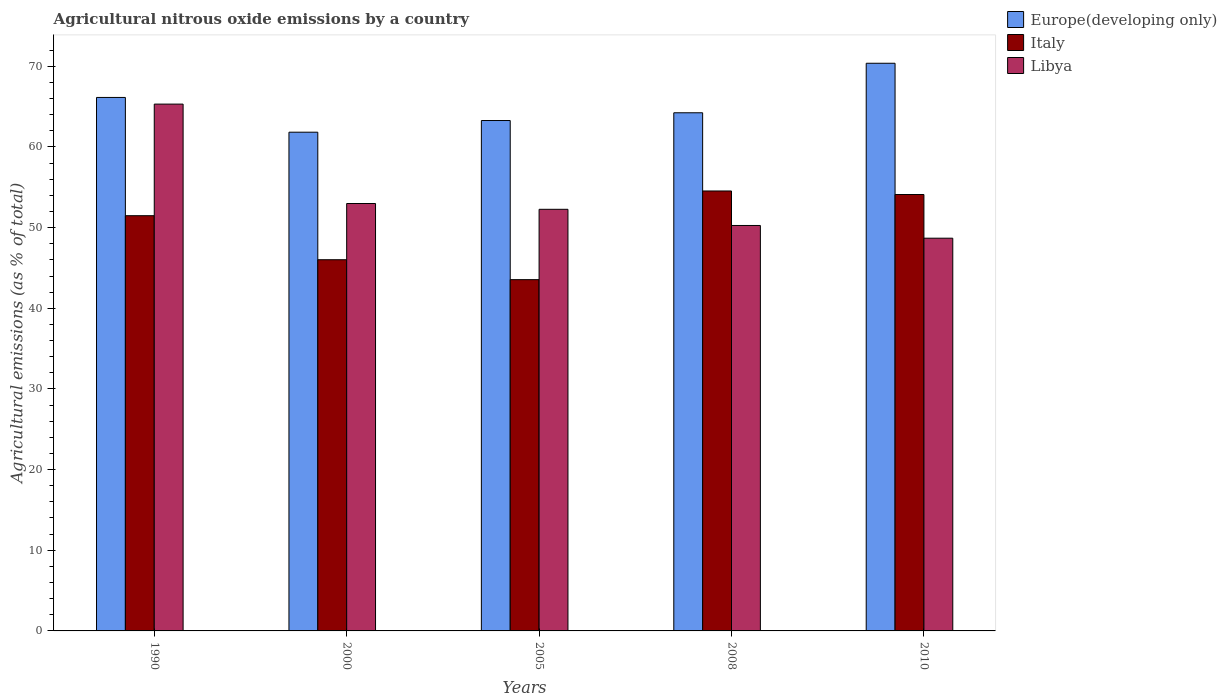How many different coloured bars are there?
Your answer should be compact. 3. How many groups of bars are there?
Offer a very short reply. 5. Are the number of bars per tick equal to the number of legend labels?
Make the answer very short. Yes. What is the amount of agricultural nitrous oxide emitted in Europe(developing only) in 2008?
Provide a short and direct response. 64.24. Across all years, what is the maximum amount of agricultural nitrous oxide emitted in Italy?
Ensure brevity in your answer.  54.54. Across all years, what is the minimum amount of agricultural nitrous oxide emitted in Europe(developing only)?
Keep it short and to the point. 61.83. In which year was the amount of agricultural nitrous oxide emitted in Libya maximum?
Give a very brief answer. 1990. In which year was the amount of agricultural nitrous oxide emitted in Europe(developing only) minimum?
Provide a short and direct response. 2000. What is the total amount of agricultural nitrous oxide emitted in Italy in the graph?
Keep it short and to the point. 249.69. What is the difference between the amount of agricultural nitrous oxide emitted in Italy in 2008 and that in 2010?
Give a very brief answer. 0.44. What is the difference between the amount of agricultural nitrous oxide emitted in Europe(developing only) in 2008 and the amount of agricultural nitrous oxide emitted in Italy in 2010?
Provide a short and direct response. 10.13. What is the average amount of agricultural nitrous oxide emitted in Europe(developing only) per year?
Offer a terse response. 65.17. In the year 1990, what is the difference between the amount of agricultural nitrous oxide emitted in Europe(developing only) and amount of agricultural nitrous oxide emitted in Italy?
Offer a terse response. 14.66. In how many years, is the amount of agricultural nitrous oxide emitted in Libya greater than 16 %?
Your response must be concise. 5. What is the ratio of the amount of agricultural nitrous oxide emitted in Europe(developing only) in 1990 to that in 2000?
Give a very brief answer. 1.07. Is the difference between the amount of agricultural nitrous oxide emitted in Europe(developing only) in 2005 and 2010 greater than the difference between the amount of agricultural nitrous oxide emitted in Italy in 2005 and 2010?
Provide a short and direct response. Yes. What is the difference between the highest and the second highest amount of agricultural nitrous oxide emitted in Europe(developing only)?
Offer a terse response. 4.24. What is the difference between the highest and the lowest amount of agricultural nitrous oxide emitted in Italy?
Keep it short and to the point. 10.99. In how many years, is the amount of agricultural nitrous oxide emitted in Italy greater than the average amount of agricultural nitrous oxide emitted in Italy taken over all years?
Keep it short and to the point. 3. Is the sum of the amount of agricultural nitrous oxide emitted in Italy in 2005 and 2008 greater than the maximum amount of agricultural nitrous oxide emitted in Libya across all years?
Provide a succinct answer. Yes. What does the 3rd bar from the left in 2000 represents?
Keep it short and to the point. Libya. What does the 1st bar from the right in 2008 represents?
Offer a terse response. Libya. Are all the bars in the graph horizontal?
Keep it short and to the point. No. Does the graph contain any zero values?
Offer a very short reply. No. Does the graph contain grids?
Make the answer very short. No. How many legend labels are there?
Keep it short and to the point. 3. What is the title of the graph?
Keep it short and to the point. Agricultural nitrous oxide emissions by a country. What is the label or title of the Y-axis?
Provide a succinct answer. Agricultural emissions (as % of total). What is the Agricultural emissions (as % of total) of Europe(developing only) in 1990?
Your response must be concise. 66.14. What is the Agricultural emissions (as % of total) of Italy in 1990?
Your answer should be compact. 51.48. What is the Agricultural emissions (as % of total) of Libya in 1990?
Offer a very short reply. 65.31. What is the Agricultural emissions (as % of total) of Europe(developing only) in 2000?
Keep it short and to the point. 61.83. What is the Agricultural emissions (as % of total) of Italy in 2000?
Keep it short and to the point. 46.02. What is the Agricultural emissions (as % of total) of Libya in 2000?
Offer a terse response. 52.99. What is the Agricultural emissions (as % of total) of Europe(developing only) in 2005?
Offer a terse response. 63.28. What is the Agricultural emissions (as % of total) of Italy in 2005?
Keep it short and to the point. 43.55. What is the Agricultural emissions (as % of total) of Libya in 2005?
Your answer should be very brief. 52.27. What is the Agricultural emissions (as % of total) of Europe(developing only) in 2008?
Provide a short and direct response. 64.24. What is the Agricultural emissions (as % of total) in Italy in 2008?
Ensure brevity in your answer.  54.54. What is the Agricultural emissions (as % of total) in Libya in 2008?
Provide a succinct answer. 50.27. What is the Agricultural emissions (as % of total) of Europe(developing only) in 2010?
Provide a succinct answer. 70.38. What is the Agricultural emissions (as % of total) in Italy in 2010?
Your answer should be very brief. 54.1. What is the Agricultural emissions (as % of total) in Libya in 2010?
Your response must be concise. 48.69. Across all years, what is the maximum Agricultural emissions (as % of total) of Europe(developing only)?
Make the answer very short. 70.38. Across all years, what is the maximum Agricultural emissions (as % of total) in Italy?
Your answer should be very brief. 54.54. Across all years, what is the maximum Agricultural emissions (as % of total) in Libya?
Offer a terse response. 65.31. Across all years, what is the minimum Agricultural emissions (as % of total) in Europe(developing only)?
Ensure brevity in your answer.  61.83. Across all years, what is the minimum Agricultural emissions (as % of total) in Italy?
Provide a succinct answer. 43.55. Across all years, what is the minimum Agricultural emissions (as % of total) in Libya?
Your answer should be very brief. 48.69. What is the total Agricultural emissions (as % of total) in Europe(developing only) in the graph?
Offer a very short reply. 325.86. What is the total Agricultural emissions (as % of total) in Italy in the graph?
Your response must be concise. 249.69. What is the total Agricultural emissions (as % of total) in Libya in the graph?
Give a very brief answer. 269.53. What is the difference between the Agricultural emissions (as % of total) of Europe(developing only) in 1990 and that in 2000?
Provide a short and direct response. 4.31. What is the difference between the Agricultural emissions (as % of total) of Italy in 1990 and that in 2000?
Your answer should be compact. 5.46. What is the difference between the Agricultural emissions (as % of total) in Libya in 1990 and that in 2000?
Your response must be concise. 12.32. What is the difference between the Agricultural emissions (as % of total) in Europe(developing only) in 1990 and that in 2005?
Give a very brief answer. 2.86. What is the difference between the Agricultural emissions (as % of total) of Italy in 1990 and that in 2005?
Keep it short and to the point. 7.93. What is the difference between the Agricultural emissions (as % of total) in Libya in 1990 and that in 2005?
Your answer should be very brief. 13.04. What is the difference between the Agricultural emissions (as % of total) in Europe(developing only) in 1990 and that in 2008?
Your response must be concise. 1.9. What is the difference between the Agricultural emissions (as % of total) of Italy in 1990 and that in 2008?
Give a very brief answer. -3.06. What is the difference between the Agricultural emissions (as % of total) in Libya in 1990 and that in 2008?
Make the answer very short. 15.05. What is the difference between the Agricultural emissions (as % of total) in Europe(developing only) in 1990 and that in 2010?
Offer a very short reply. -4.24. What is the difference between the Agricultural emissions (as % of total) in Italy in 1990 and that in 2010?
Offer a very short reply. -2.63. What is the difference between the Agricultural emissions (as % of total) of Libya in 1990 and that in 2010?
Ensure brevity in your answer.  16.62. What is the difference between the Agricultural emissions (as % of total) of Europe(developing only) in 2000 and that in 2005?
Keep it short and to the point. -1.45. What is the difference between the Agricultural emissions (as % of total) of Italy in 2000 and that in 2005?
Keep it short and to the point. 2.47. What is the difference between the Agricultural emissions (as % of total) in Libya in 2000 and that in 2005?
Keep it short and to the point. 0.72. What is the difference between the Agricultural emissions (as % of total) in Europe(developing only) in 2000 and that in 2008?
Offer a terse response. -2.41. What is the difference between the Agricultural emissions (as % of total) in Italy in 2000 and that in 2008?
Your answer should be compact. -8.52. What is the difference between the Agricultural emissions (as % of total) in Libya in 2000 and that in 2008?
Give a very brief answer. 2.72. What is the difference between the Agricultural emissions (as % of total) of Europe(developing only) in 2000 and that in 2010?
Your answer should be compact. -8.55. What is the difference between the Agricultural emissions (as % of total) in Italy in 2000 and that in 2010?
Keep it short and to the point. -8.09. What is the difference between the Agricultural emissions (as % of total) of Libya in 2000 and that in 2010?
Your answer should be compact. 4.3. What is the difference between the Agricultural emissions (as % of total) in Europe(developing only) in 2005 and that in 2008?
Your answer should be compact. -0.96. What is the difference between the Agricultural emissions (as % of total) of Italy in 2005 and that in 2008?
Offer a terse response. -10.99. What is the difference between the Agricultural emissions (as % of total) of Libya in 2005 and that in 2008?
Provide a short and direct response. 2. What is the difference between the Agricultural emissions (as % of total) of Europe(developing only) in 2005 and that in 2010?
Make the answer very short. -7.1. What is the difference between the Agricultural emissions (as % of total) in Italy in 2005 and that in 2010?
Give a very brief answer. -10.56. What is the difference between the Agricultural emissions (as % of total) of Libya in 2005 and that in 2010?
Give a very brief answer. 3.58. What is the difference between the Agricultural emissions (as % of total) of Europe(developing only) in 2008 and that in 2010?
Provide a succinct answer. -6.14. What is the difference between the Agricultural emissions (as % of total) in Italy in 2008 and that in 2010?
Keep it short and to the point. 0.44. What is the difference between the Agricultural emissions (as % of total) of Libya in 2008 and that in 2010?
Offer a very short reply. 1.58. What is the difference between the Agricultural emissions (as % of total) of Europe(developing only) in 1990 and the Agricultural emissions (as % of total) of Italy in 2000?
Keep it short and to the point. 20.12. What is the difference between the Agricultural emissions (as % of total) of Europe(developing only) in 1990 and the Agricultural emissions (as % of total) of Libya in 2000?
Keep it short and to the point. 13.15. What is the difference between the Agricultural emissions (as % of total) in Italy in 1990 and the Agricultural emissions (as % of total) in Libya in 2000?
Your answer should be very brief. -1.51. What is the difference between the Agricultural emissions (as % of total) in Europe(developing only) in 1990 and the Agricultural emissions (as % of total) in Italy in 2005?
Provide a short and direct response. 22.59. What is the difference between the Agricultural emissions (as % of total) in Europe(developing only) in 1990 and the Agricultural emissions (as % of total) in Libya in 2005?
Your answer should be compact. 13.87. What is the difference between the Agricultural emissions (as % of total) in Italy in 1990 and the Agricultural emissions (as % of total) in Libya in 2005?
Give a very brief answer. -0.79. What is the difference between the Agricultural emissions (as % of total) of Europe(developing only) in 1990 and the Agricultural emissions (as % of total) of Italy in 2008?
Your answer should be very brief. 11.6. What is the difference between the Agricultural emissions (as % of total) in Europe(developing only) in 1990 and the Agricultural emissions (as % of total) in Libya in 2008?
Offer a very short reply. 15.87. What is the difference between the Agricultural emissions (as % of total) in Italy in 1990 and the Agricultural emissions (as % of total) in Libya in 2008?
Provide a short and direct response. 1.21. What is the difference between the Agricultural emissions (as % of total) of Europe(developing only) in 1990 and the Agricultural emissions (as % of total) of Italy in 2010?
Keep it short and to the point. 12.03. What is the difference between the Agricultural emissions (as % of total) in Europe(developing only) in 1990 and the Agricultural emissions (as % of total) in Libya in 2010?
Keep it short and to the point. 17.45. What is the difference between the Agricultural emissions (as % of total) of Italy in 1990 and the Agricultural emissions (as % of total) of Libya in 2010?
Your answer should be very brief. 2.79. What is the difference between the Agricultural emissions (as % of total) in Europe(developing only) in 2000 and the Agricultural emissions (as % of total) in Italy in 2005?
Your answer should be compact. 18.28. What is the difference between the Agricultural emissions (as % of total) in Europe(developing only) in 2000 and the Agricultural emissions (as % of total) in Libya in 2005?
Your response must be concise. 9.56. What is the difference between the Agricultural emissions (as % of total) in Italy in 2000 and the Agricultural emissions (as % of total) in Libya in 2005?
Make the answer very short. -6.25. What is the difference between the Agricultural emissions (as % of total) of Europe(developing only) in 2000 and the Agricultural emissions (as % of total) of Italy in 2008?
Provide a succinct answer. 7.29. What is the difference between the Agricultural emissions (as % of total) of Europe(developing only) in 2000 and the Agricultural emissions (as % of total) of Libya in 2008?
Your answer should be very brief. 11.56. What is the difference between the Agricultural emissions (as % of total) in Italy in 2000 and the Agricultural emissions (as % of total) in Libya in 2008?
Your answer should be very brief. -4.25. What is the difference between the Agricultural emissions (as % of total) in Europe(developing only) in 2000 and the Agricultural emissions (as % of total) in Italy in 2010?
Offer a terse response. 7.73. What is the difference between the Agricultural emissions (as % of total) in Europe(developing only) in 2000 and the Agricultural emissions (as % of total) in Libya in 2010?
Provide a short and direct response. 13.14. What is the difference between the Agricultural emissions (as % of total) in Italy in 2000 and the Agricultural emissions (as % of total) in Libya in 2010?
Your answer should be compact. -2.67. What is the difference between the Agricultural emissions (as % of total) of Europe(developing only) in 2005 and the Agricultural emissions (as % of total) of Italy in 2008?
Provide a short and direct response. 8.74. What is the difference between the Agricultural emissions (as % of total) in Europe(developing only) in 2005 and the Agricultural emissions (as % of total) in Libya in 2008?
Offer a very short reply. 13.01. What is the difference between the Agricultural emissions (as % of total) in Italy in 2005 and the Agricultural emissions (as % of total) in Libya in 2008?
Give a very brief answer. -6.72. What is the difference between the Agricultural emissions (as % of total) in Europe(developing only) in 2005 and the Agricultural emissions (as % of total) in Italy in 2010?
Your answer should be very brief. 9.17. What is the difference between the Agricultural emissions (as % of total) of Europe(developing only) in 2005 and the Agricultural emissions (as % of total) of Libya in 2010?
Offer a terse response. 14.59. What is the difference between the Agricultural emissions (as % of total) in Italy in 2005 and the Agricultural emissions (as % of total) in Libya in 2010?
Provide a short and direct response. -5.14. What is the difference between the Agricultural emissions (as % of total) of Europe(developing only) in 2008 and the Agricultural emissions (as % of total) of Italy in 2010?
Provide a succinct answer. 10.13. What is the difference between the Agricultural emissions (as % of total) in Europe(developing only) in 2008 and the Agricultural emissions (as % of total) in Libya in 2010?
Ensure brevity in your answer.  15.55. What is the difference between the Agricultural emissions (as % of total) in Italy in 2008 and the Agricultural emissions (as % of total) in Libya in 2010?
Give a very brief answer. 5.85. What is the average Agricultural emissions (as % of total) in Europe(developing only) per year?
Your response must be concise. 65.17. What is the average Agricultural emissions (as % of total) in Italy per year?
Make the answer very short. 49.94. What is the average Agricultural emissions (as % of total) of Libya per year?
Keep it short and to the point. 53.91. In the year 1990, what is the difference between the Agricultural emissions (as % of total) in Europe(developing only) and Agricultural emissions (as % of total) in Italy?
Your answer should be compact. 14.66. In the year 1990, what is the difference between the Agricultural emissions (as % of total) in Europe(developing only) and Agricultural emissions (as % of total) in Libya?
Your answer should be compact. 0.83. In the year 1990, what is the difference between the Agricultural emissions (as % of total) in Italy and Agricultural emissions (as % of total) in Libya?
Give a very brief answer. -13.83. In the year 2000, what is the difference between the Agricultural emissions (as % of total) of Europe(developing only) and Agricultural emissions (as % of total) of Italy?
Provide a short and direct response. 15.81. In the year 2000, what is the difference between the Agricultural emissions (as % of total) of Europe(developing only) and Agricultural emissions (as % of total) of Libya?
Provide a succinct answer. 8.84. In the year 2000, what is the difference between the Agricultural emissions (as % of total) of Italy and Agricultural emissions (as % of total) of Libya?
Offer a terse response. -6.97. In the year 2005, what is the difference between the Agricultural emissions (as % of total) in Europe(developing only) and Agricultural emissions (as % of total) in Italy?
Offer a very short reply. 19.73. In the year 2005, what is the difference between the Agricultural emissions (as % of total) in Europe(developing only) and Agricultural emissions (as % of total) in Libya?
Give a very brief answer. 11.01. In the year 2005, what is the difference between the Agricultural emissions (as % of total) in Italy and Agricultural emissions (as % of total) in Libya?
Provide a succinct answer. -8.72. In the year 2008, what is the difference between the Agricultural emissions (as % of total) of Europe(developing only) and Agricultural emissions (as % of total) of Italy?
Keep it short and to the point. 9.7. In the year 2008, what is the difference between the Agricultural emissions (as % of total) in Europe(developing only) and Agricultural emissions (as % of total) in Libya?
Offer a terse response. 13.97. In the year 2008, what is the difference between the Agricultural emissions (as % of total) in Italy and Agricultural emissions (as % of total) in Libya?
Your answer should be compact. 4.28. In the year 2010, what is the difference between the Agricultural emissions (as % of total) of Europe(developing only) and Agricultural emissions (as % of total) of Italy?
Provide a short and direct response. 16.27. In the year 2010, what is the difference between the Agricultural emissions (as % of total) in Europe(developing only) and Agricultural emissions (as % of total) in Libya?
Your answer should be very brief. 21.69. In the year 2010, what is the difference between the Agricultural emissions (as % of total) of Italy and Agricultural emissions (as % of total) of Libya?
Offer a terse response. 5.42. What is the ratio of the Agricultural emissions (as % of total) of Europe(developing only) in 1990 to that in 2000?
Keep it short and to the point. 1.07. What is the ratio of the Agricultural emissions (as % of total) in Italy in 1990 to that in 2000?
Your answer should be very brief. 1.12. What is the ratio of the Agricultural emissions (as % of total) of Libya in 1990 to that in 2000?
Your answer should be very brief. 1.23. What is the ratio of the Agricultural emissions (as % of total) in Europe(developing only) in 1990 to that in 2005?
Ensure brevity in your answer.  1.05. What is the ratio of the Agricultural emissions (as % of total) in Italy in 1990 to that in 2005?
Make the answer very short. 1.18. What is the ratio of the Agricultural emissions (as % of total) in Libya in 1990 to that in 2005?
Offer a terse response. 1.25. What is the ratio of the Agricultural emissions (as % of total) of Europe(developing only) in 1990 to that in 2008?
Give a very brief answer. 1.03. What is the ratio of the Agricultural emissions (as % of total) of Italy in 1990 to that in 2008?
Provide a short and direct response. 0.94. What is the ratio of the Agricultural emissions (as % of total) of Libya in 1990 to that in 2008?
Offer a terse response. 1.3. What is the ratio of the Agricultural emissions (as % of total) in Europe(developing only) in 1990 to that in 2010?
Give a very brief answer. 0.94. What is the ratio of the Agricultural emissions (as % of total) in Italy in 1990 to that in 2010?
Provide a short and direct response. 0.95. What is the ratio of the Agricultural emissions (as % of total) of Libya in 1990 to that in 2010?
Provide a short and direct response. 1.34. What is the ratio of the Agricultural emissions (as % of total) of Europe(developing only) in 2000 to that in 2005?
Offer a very short reply. 0.98. What is the ratio of the Agricultural emissions (as % of total) of Italy in 2000 to that in 2005?
Provide a short and direct response. 1.06. What is the ratio of the Agricultural emissions (as % of total) of Libya in 2000 to that in 2005?
Provide a short and direct response. 1.01. What is the ratio of the Agricultural emissions (as % of total) in Europe(developing only) in 2000 to that in 2008?
Keep it short and to the point. 0.96. What is the ratio of the Agricultural emissions (as % of total) in Italy in 2000 to that in 2008?
Offer a terse response. 0.84. What is the ratio of the Agricultural emissions (as % of total) in Libya in 2000 to that in 2008?
Provide a succinct answer. 1.05. What is the ratio of the Agricultural emissions (as % of total) of Europe(developing only) in 2000 to that in 2010?
Offer a very short reply. 0.88. What is the ratio of the Agricultural emissions (as % of total) in Italy in 2000 to that in 2010?
Ensure brevity in your answer.  0.85. What is the ratio of the Agricultural emissions (as % of total) in Libya in 2000 to that in 2010?
Provide a short and direct response. 1.09. What is the ratio of the Agricultural emissions (as % of total) of Europe(developing only) in 2005 to that in 2008?
Your answer should be very brief. 0.98. What is the ratio of the Agricultural emissions (as % of total) of Italy in 2005 to that in 2008?
Give a very brief answer. 0.8. What is the ratio of the Agricultural emissions (as % of total) in Libya in 2005 to that in 2008?
Offer a terse response. 1.04. What is the ratio of the Agricultural emissions (as % of total) in Europe(developing only) in 2005 to that in 2010?
Provide a short and direct response. 0.9. What is the ratio of the Agricultural emissions (as % of total) of Italy in 2005 to that in 2010?
Offer a very short reply. 0.8. What is the ratio of the Agricultural emissions (as % of total) in Libya in 2005 to that in 2010?
Your answer should be very brief. 1.07. What is the ratio of the Agricultural emissions (as % of total) in Europe(developing only) in 2008 to that in 2010?
Keep it short and to the point. 0.91. What is the ratio of the Agricultural emissions (as % of total) of Italy in 2008 to that in 2010?
Offer a very short reply. 1.01. What is the ratio of the Agricultural emissions (as % of total) of Libya in 2008 to that in 2010?
Your response must be concise. 1.03. What is the difference between the highest and the second highest Agricultural emissions (as % of total) in Europe(developing only)?
Offer a terse response. 4.24. What is the difference between the highest and the second highest Agricultural emissions (as % of total) in Italy?
Offer a terse response. 0.44. What is the difference between the highest and the second highest Agricultural emissions (as % of total) of Libya?
Your answer should be very brief. 12.32. What is the difference between the highest and the lowest Agricultural emissions (as % of total) of Europe(developing only)?
Offer a very short reply. 8.55. What is the difference between the highest and the lowest Agricultural emissions (as % of total) of Italy?
Keep it short and to the point. 10.99. What is the difference between the highest and the lowest Agricultural emissions (as % of total) in Libya?
Give a very brief answer. 16.62. 